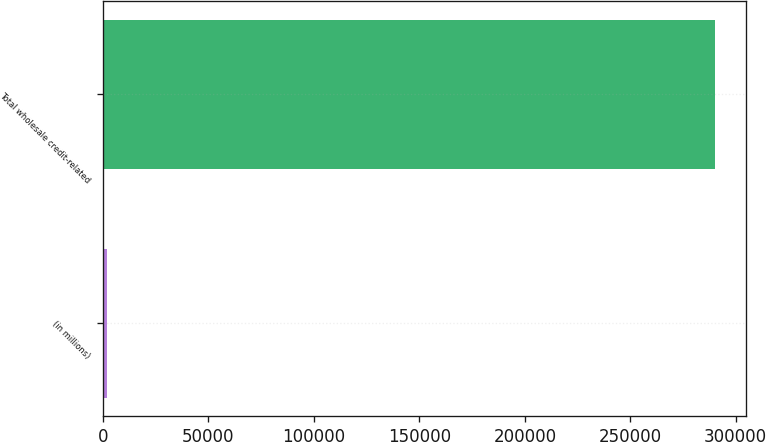Convert chart. <chart><loc_0><loc_0><loc_500><loc_500><bar_chart><fcel>(in millions)<fcel>Total wholesale credit-related<nl><fcel>2007<fcel>290212<nl></chart> 